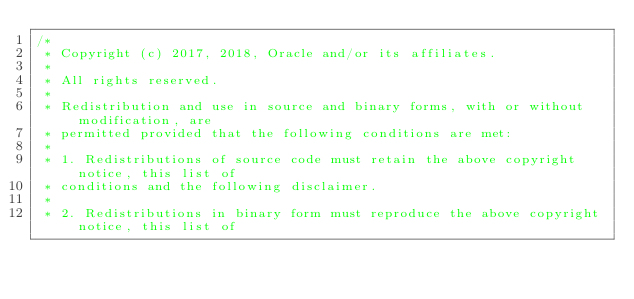<code> <loc_0><loc_0><loc_500><loc_500><_C_>/*
 * Copyright (c) 2017, 2018, Oracle and/or its affiliates.
 *
 * All rights reserved.
 *
 * Redistribution and use in source and binary forms, with or without modification, are
 * permitted provided that the following conditions are met:
 *
 * 1. Redistributions of source code must retain the above copyright notice, this list of
 * conditions and the following disclaimer.
 *
 * 2. Redistributions in binary form must reproduce the above copyright notice, this list of</code> 